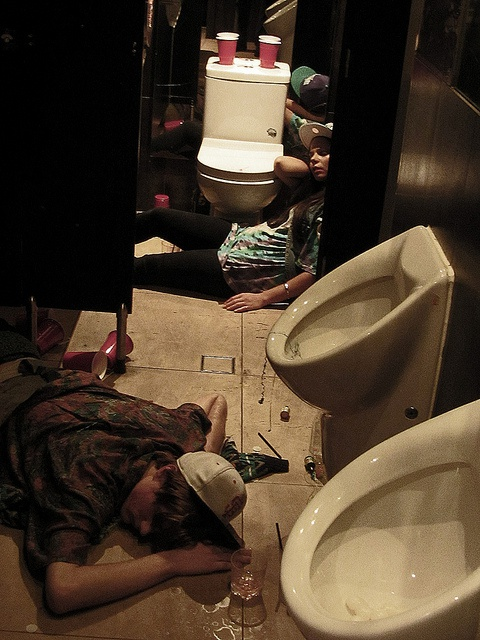Describe the objects in this image and their specific colors. I can see people in black, maroon, and tan tones, toilet in black, tan, and gray tones, toilet in black, maroon, and tan tones, people in black, maroon, and gray tones, and toilet in black, ivory, and tan tones in this image. 